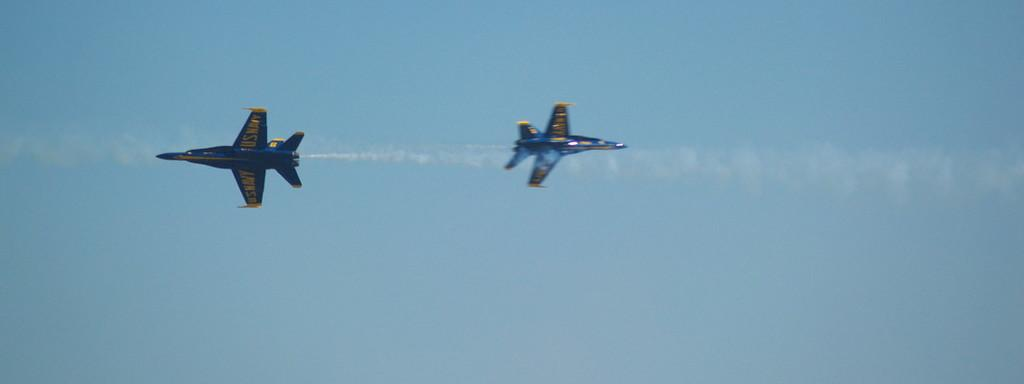What type of vehicles are in the image? There are two jet aeroplanes in the image. Where are the aeroplanes located in the image? The aeroplanes are in the middle of the image. What can be seen in the background of the image? There is a sky visible in the background of the image. What type of quiver is visible in the image? There is no quiver present in the image; it features two jet aeroplanes and a sky background. Can you tell me how many times the aeroplanes fly in the image? The image is a still photograph, so the aeroplanes are not flying; they are stationary in the image. 